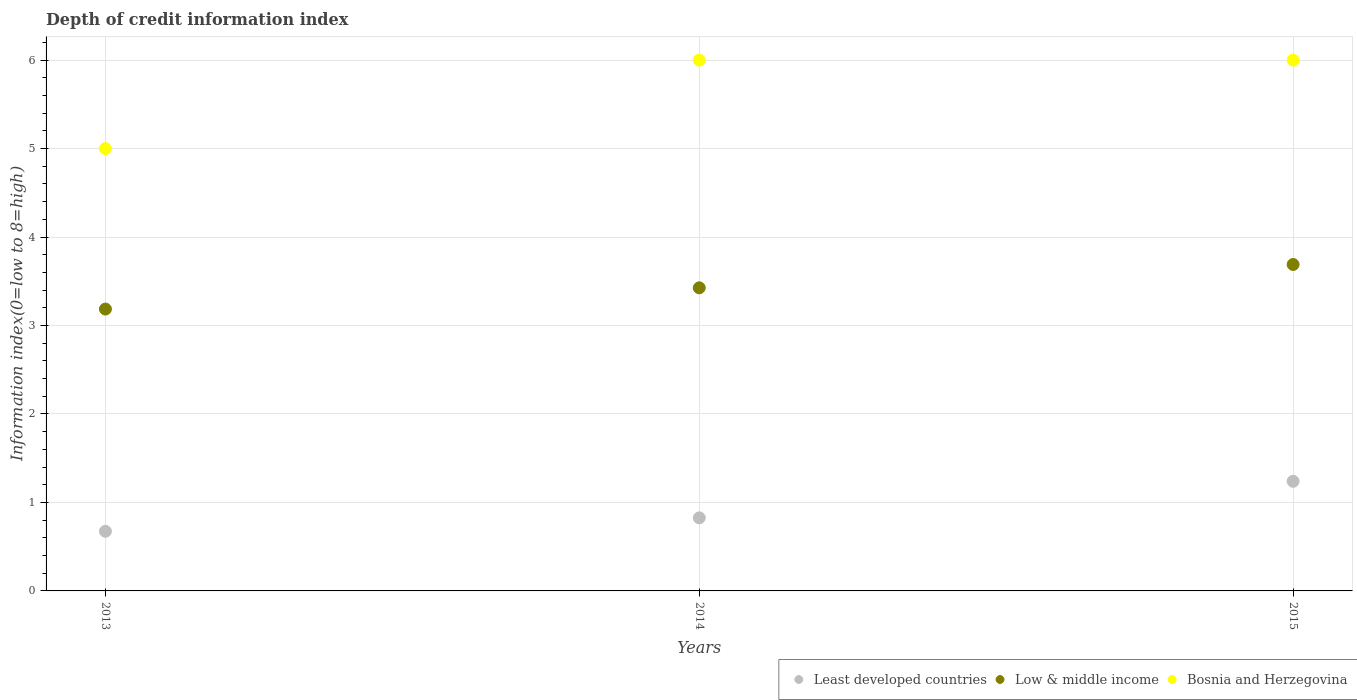How many different coloured dotlines are there?
Your answer should be compact. 3. Is the number of dotlines equal to the number of legend labels?
Keep it short and to the point. Yes. Across all years, what is the maximum information index in Low & middle income?
Your response must be concise. 3.69. Across all years, what is the minimum information index in Low & middle income?
Your answer should be compact. 3.19. In which year was the information index in Least developed countries maximum?
Give a very brief answer. 2015. In which year was the information index in Bosnia and Herzegovina minimum?
Ensure brevity in your answer.  2013. What is the total information index in Low & middle income in the graph?
Make the answer very short. 10.3. What is the difference between the information index in Low & middle income in 2013 and that in 2015?
Keep it short and to the point. -0.5. What is the difference between the information index in Least developed countries in 2015 and the information index in Low & middle income in 2013?
Ensure brevity in your answer.  -1.95. What is the average information index in Least developed countries per year?
Keep it short and to the point. 0.91. In the year 2014, what is the difference between the information index in Low & middle income and information index in Bosnia and Herzegovina?
Your answer should be compact. -2.57. What is the ratio of the information index in Low & middle income in 2014 to that in 2015?
Provide a short and direct response. 0.93. Is the information index in Least developed countries in 2013 less than that in 2015?
Keep it short and to the point. Yes. What is the difference between the highest and the second highest information index in Low & middle income?
Offer a terse response. 0.26. What is the difference between the highest and the lowest information index in Least developed countries?
Provide a short and direct response. 0.57. In how many years, is the information index in Least developed countries greater than the average information index in Least developed countries taken over all years?
Your answer should be very brief. 1. Is it the case that in every year, the sum of the information index in Least developed countries and information index in Bosnia and Herzegovina  is greater than the information index in Low & middle income?
Keep it short and to the point. Yes. Does the information index in Low & middle income monotonically increase over the years?
Offer a terse response. Yes. Is the information index in Least developed countries strictly greater than the information index in Low & middle income over the years?
Offer a very short reply. No. Is the information index in Least developed countries strictly less than the information index in Low & middle income over the years?
Provide a short and direct response. Yes. How many dotlines are there?
Your response must be concise. 3. How many years are there in the graph?
Provide a succinct answer. 3. Does the graph contain grids?
Your response must be concise. Yes. How many legend labels are there?
Provide a succinct answer. 3. What is the title of the graph?
Your response must be concise. Depth of credit information index. Does "Lebanon" appear as one of the legend labels in the graph?
Give a very brief answer. No. What is the label or title of the X-axis?
Your response must be concise. Years. What is the label or title of the Y-axis?
Keep it short and to the point. Information index(0=low to 8=high). What is the Information index(0=low to 8=high) of Least developed countries in 2013?
Make the answer very short. 0.67. What is the Information index(0=low to 8=high) in Low & middle income in 2013?
Provide a short and direct response. 3.19. What is the Information index(0=low to 8=high) in Bosnia and Herzegovina in 2013?
Offer a very short reply. 5. What is the Information index(0=low to 8=high) of Least developed countries in 2014?
Offer a very short reply. 0.83. What is the Information index(0=low to 8=high) in Low & middle income in 2014?
Give a very brief answer. 3.43. What is the Information index(0=low to 8=high) in Bosnia and Herzegovina in 2014?
Provide a succinct answer. 6. What is the Information index(0=low to 8=high) of Least developed countries in 2015?
Offer a terse response. 1.24. What is the Information index(0=low to 8=high) in Low & middle income in 2015?
Provide a short and direct response. 3.69. Across all years, what is the maximum Information index(0=low to 8=high) of Least developed countries?
Provide a succinct answer. 1.24. Across all years, what is the maximum Information index(0=low to 8=high) of Low & middle income?
Offer a very short reply. 3.69. Across all years, what is the minimum Information index(0=low to 8=high) of Least developed countries?
Ensure brevity in your answer.  0.67. Across all years, what is the minimum Information index(0=low to 8=high) in Low & middle income?
Keep it short and to the point. 3.19. Across all years, what is the minimum Information index(0=low to 8=high) in Bosnia and Herzegovina?
Offer a terse response. 5. What is the total Information index(0=low to 8=high) in Least developed countries in the graph?
Offer a terse response. 2.74. What is the total Information index(0=low to 8=high) of Low & middle income in the graph?
Give a very brief answer. 10.3. What is the difference between the Information index(0=low to 8=high) in Least developed countries in 2013 and that in 2014?
Provide a short and direct response. -0.15. What is the difference between the Information index(0=low to 8=high) in Low & middle income in 2013 and that in 2014?
Your answer should be very brief. -0.24. What is the difference between the Information index(0=low to 8=high) of Bosnia and Herzegovina in 2013 and that in 2014?
Your response must be concise. -1. What is the difference between the Information index(0=low to 8=high) in Least developed countries in 2013 and that in 2015?
Provide a succinct answer. -0.57. What is the difference between the Information index(0=low to 8=high) of Low & middle income in 2013 and that in 2015?
Your answer should be very brief. -0.5. What is the difference between the Information index(0=low to 8=high) in Least developed countries in 2014 and that in 2015?
Ensure brevity in your answer.  -0.41. What is the difference between the Information index(0=low to 8=high) of Low & middle income in 2014 and that in 2015?
Offer a terse response. -0.26. What is the difference between the Information index(0=low to 8=high) of Bosnia and Herzegovina in 2014 and that in 2015?
Your response must be concise. 0. What is the difference between the Information index(0=low to 8=high) of Least developed countries in 2013 and the Information index(0=low to 8=high) of Low & middle income in 2014?
Make the answer very short. -2.75. What is the difference between the Information index(0=low to 8=high) of Least developed countries in 2013 and the Information index(0=low to 8=high) of Bosnia and Herzegovina in 2014?
Ensure brevity in your answer.  -5.33. What is the difference between the Information index(0=low to 8=high) of Low & middle income in 2013 and the Information index(0=low to 8=high) of Bosnia and Herzegovina in 2014?
Offer a terse response. -2.81. What is the difference between the Information index(0=low to 8=high) in Least developed countries in 2013 and the Information index(0=low to 8=high) in Low & middle income in 2015?
Your answer should be very brief. -3.02. What is the difference between the Information index(0=low to 8=high) of Least developed countries in 2013 and the Information index(0=low to 8=high) of Bosnia and Herzegovina in 2015?
Provide a succinct answer. -5.33. What is the difference between the Information index(0=low to 8=high) of Low & middle income in 2013 and the Information index(0=low to 8=high) of Bosnia and Herzegovina in 2015?
Keep it short and to the point. -2.81. What is the difference between the Information index(0=low to 8=high) in Least developed countries in 2014 and the Information index(0=low to 8=high) in Low & middle income in 2015?
Your answer should be compact. -2.86. What is the difference between the Information index(0=low to 8=high) in Least developed countries in 2014 and the Information index(0=low to 8=high) in Bosnia and Herzegovina in 2015?
Your response must be concise. -5.17. What is the difference between the Information index(0=low to 8=high) of Low & middle income in 2014 and the Information index(0=low to 8=high) of Bosnia and Herzegovina in 2015?
Give a very brief answer. -2.57. What is the average Information index(0=low to 8=high) in Least developed countries per year?
Provide a succinct answer. 0.91. What is the average Information index(0=low to 8=high) of Low & middle income per year?
Your answer should be very brief. 3.43. What is the average Information index(0=low to 8=high) of Bosnia and Herzegovina per year?
Offer a terse response. 5.67. In the year 2013, what is the difference between the Information index(0=low to 8=high) in Least developed countries and Information index(0=low to 8=high) in Low & middle income?
Your answer should be very brief. -2.51. In the year 2013, what is the difference between the Information index(0=low to 8=high) in Least developed countries and Information index(0=low to 8=high) in Bosnia and Herzegovina?
Your answer should be compact. -4.33. In the year 2013, what is the difference between the Information index(0=low to 8=high) in Low & middle income and Information index(0=low to 8=high) in Bosnia and Herzegovina?
Your response must be concise. -1.81. In the year 2014, what is the difference between the Information index(0=low to 8=high) of Least developed countries and Information index(0=low to 8=high) of Low & middle income?
Your response must be concise. -2.6. In the year 2014, what is the difference between the Information index(0=low to 8=high) of Least developed countries and Information index(0=low to 8=high) of Bosnia and Herzegovina?
Your response must be concise. -5.17. In the year 2014, what is the difference between the Information index(0=low to 8=high) in Low & middle income and Information index(0=low to 8=high) in Bosnia and Herzegovina?
Provide a succinct answer. -2.57. In the year 2015, what is the difference between the Information index(0=low to 8=high) of Least developed countries and Information index(0=low to 8=high) of Low & middle income?
Your answer should be very brief. -2.45. In the year 2015, what is the difference between the Information index(0=low to 8=high) of Least developed countries and Information index(0=low to 8=high) of Bosnia and Herzegovina?
Your answer should be very brief. -4.76. In the year 2015, what is the difference between the Information index(0=low to 8=high) of Low & middle income and Information index(0=low to 8=high) of Bosnia and Herzegovina?
Offer a terse response. -2.31. What is the ratio of the Information index(0=low to 8=high) in Least developed countries in 2013 to that in 2014?
Offer a terse response. 0.82. What is the ratio of the Information index(0=low to 8=high) of Low & middle income in 2013 to that in 2014?
Provide a short and direct response. 0.93. What is the ratio of the Information index(0=low to 8=high) of Bosnia and Herzegovina in 2013 to that in 2014?
Ensure brevity in your answer.  0.83. What is the ratio of the Information index(0=low to 8=high) in Least developed countries in 2013 to that in 2015?
Provide a short and direct response. 0.54. What is the ratio of the Information index(0=low to 8=high) in Low & middle income in 2013 to that in 2015?
Your answer should be very brief. 0.86. What is the ratio of the Information index(0=low to 8=high) in Bosnia and Herzegovina in 2013 to that in 2015?
Your answer should be compact. 0.83. What is the ratio of the Information index(0=low to 8=high) of Least developed countries in 2014 to that in 2015?
Offer a very short reply. 0.67. What is the difference between the highest and the second highest Information index(0=low to 8=high) in Least developed countries?
Provide a short and direct response. 0.41. What is the difference between the highest and the second highest Information index(0=low to 8=high) of Low & middle income?
Make the answer very short. 0.26. What is the difference between the highest and the lowest Information index(0=low to 8=high) in Least developed countries?
Your response must be concise. 0.57. What is the difference between the highest and the lowest Information index(0=low to 8=high) in Low & middle income?
Offer a terse response. 0.5. 